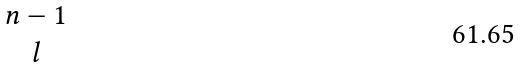Convert formula to latex. <formula><loc_0><loc_0><loc_500><loc_500>\begin{matrix} n - 1 \\ l \end{matrix}</formula> 